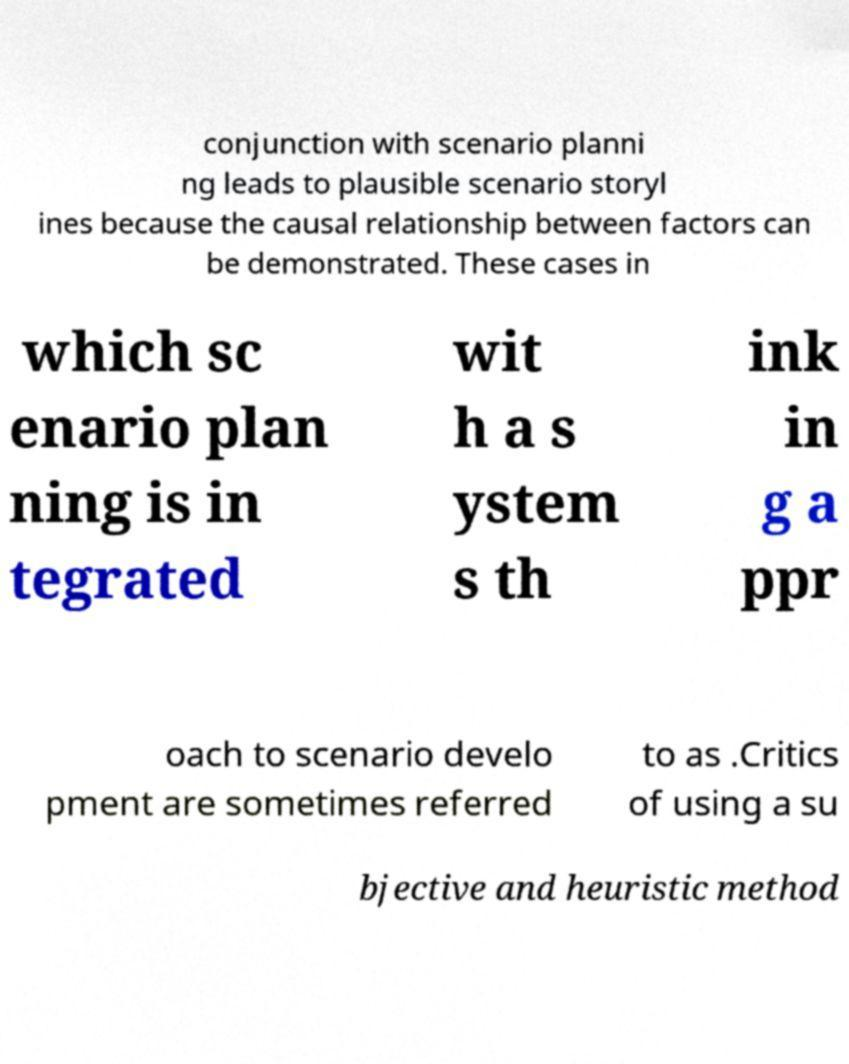Could you extract and type out the text from this image? conjunction with scenario planni ng leads to plausible scenario storyl ines because the causal relationship between factors can be demonstrated. These cases in which sc enario plan ning is in tegrated wit h a s ystem s th ink in g a ppr oach to scenario develo pment are sometimes referred to as .Critics of using a su bjective and heuristic method 